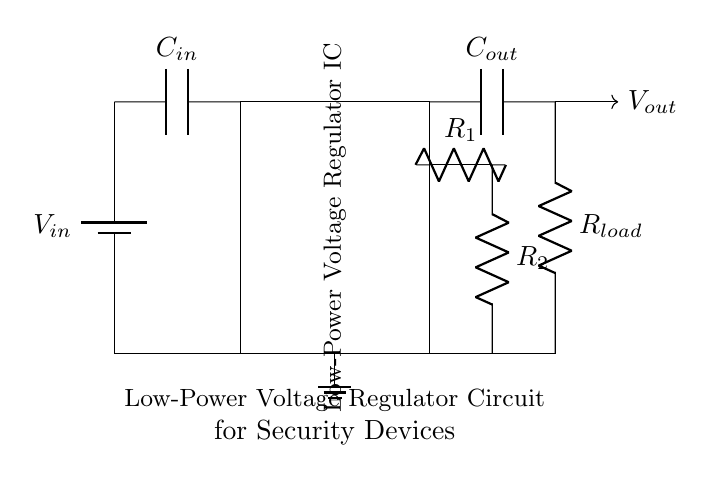What is the input voltage source in this circuit? The circuit features a battery as the input voltage source, labeled as V-in. It provides the necessary voltage for the circuit's operation.
Answer: V-in What type of device does R-load represent? In this circuit, R-load is used to represent the load connected to the voltage regulator, which, in this context, refers to the security devices drawing power.
Answer: Security devices How many capacitors are present in this circuit? Upon examining the diagram, it is clear there are two capacitors indicated: C-in at the input and C-out at the output, each serving its purpose in the regulation process.
Answer: Two What is the role of the voltage regulator IC? The low-power voltage regulator IC in the circuit ensures that the output voltage remains stable regardless of variations in input voltage or load conditions, crucial for powering sensitive security devices reliably.
Answer: Stabilize voltage What happens to the output voltage as the load changes? As the load changes, the feedback system provided by resistors R-1 and R-2 helps maintain the output voltage at a constant level, ensuring the voltage regulator delivers consistent performance to the connected devices, even in varying operational conditions.
Answer: Remains stable What components are used for feedback in this circuit? The feedback mechanism is implemented using two resistors labeled R-1 and R-2, which are connected to the output to sense the output voltage and adjust accordingly to maintain regulation.
Answer: R-1 and R-2 What is the purpose of the input capacitor C-in? The input capacitor C-in acts as a filter, smoothing out any voltage fluctuations from the battery source to provide a steady voltage level to the voltage regulator circuit, optimizing performance and reliability.
Answer: Filter voltage fluctuations 